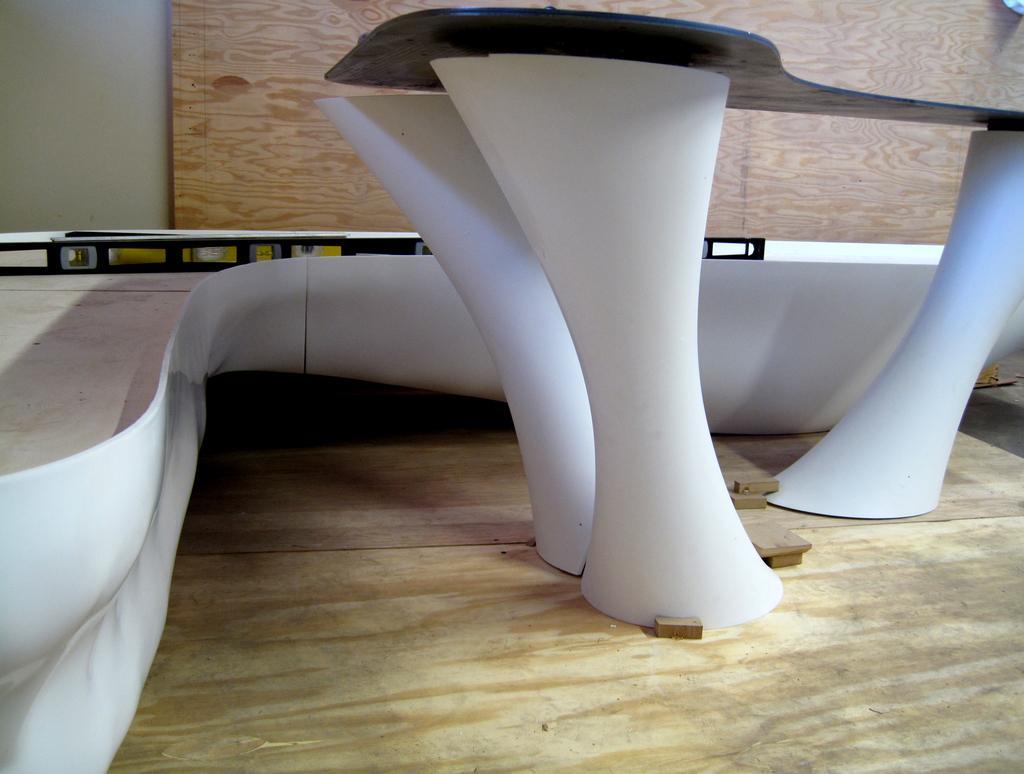How would you summarize this image in a sentence or two? In this image there is a table, in the background there is an object and a wooden wall. 